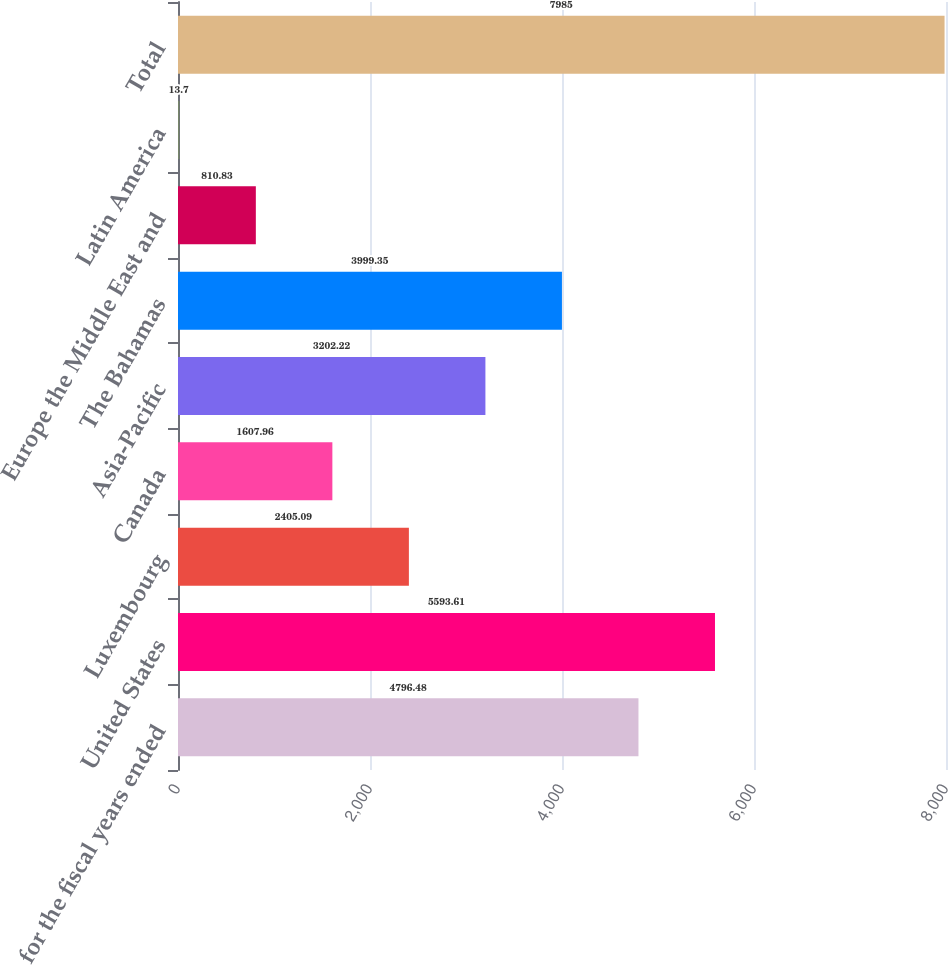Convert chart. <chart><loc_0><loc_0><loc_500><loc_500><bar_chart><fcel>for the fiscal years ended<fcel>United States<fcel>Luxembourg<fcel>Canada<fcel>Asia-Pacific<fcel>The Bahamas<fcel>Europe the Middle East and<fcel>Latin America<fcel>Total<nl><fcel>4796.48<fcel>5593.61<fcel>2405.09<fcel>1607.96<fcel>3202.22<fcel>3999.35<fcel>810.83<fcel>13.7<fcel>7985<nl></chart> 